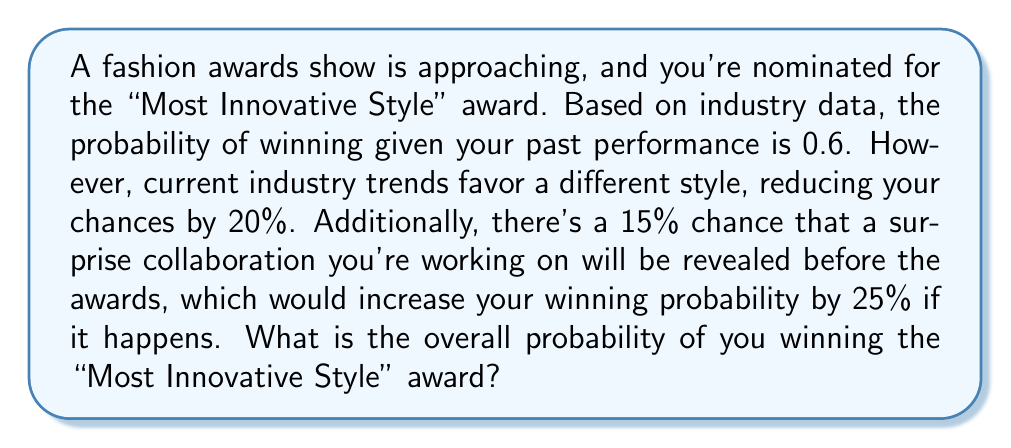Help me with this question. Let's approach this step-by-step:

1) First, let's define our events:
   A: Winning the award
   B: Surprise collaboration revealed

2) Given probabilities:
   P(A | no collaboration) = 0.6 * 0.8 = 0.48 (initial probability reduced by 20%)
   P(B) = 0.15 (probability of collaboration being revealed)
   
3) If the collaboration is revealed, the probability increases by 25%:
   P(A | B) = 0.48 * 1.25 = 0.6

4) We can use the law of total probability:
   $$P(A) = P(A|B) \cdot P(B) + P(A|\text{not }B) \cdot P(\text{not }B)$$

5) Substituting the values:
   $$P(A) = 0.6 \cdot 0.15 + 0.48 \cdot 0.85$$

6) Calculating:
   $$P(A) = 0.09 + 0.408 = 0.498$$

Therefore, the overall probability of winning the award is 0.498 or 49.8%.
Answer: 0.498 